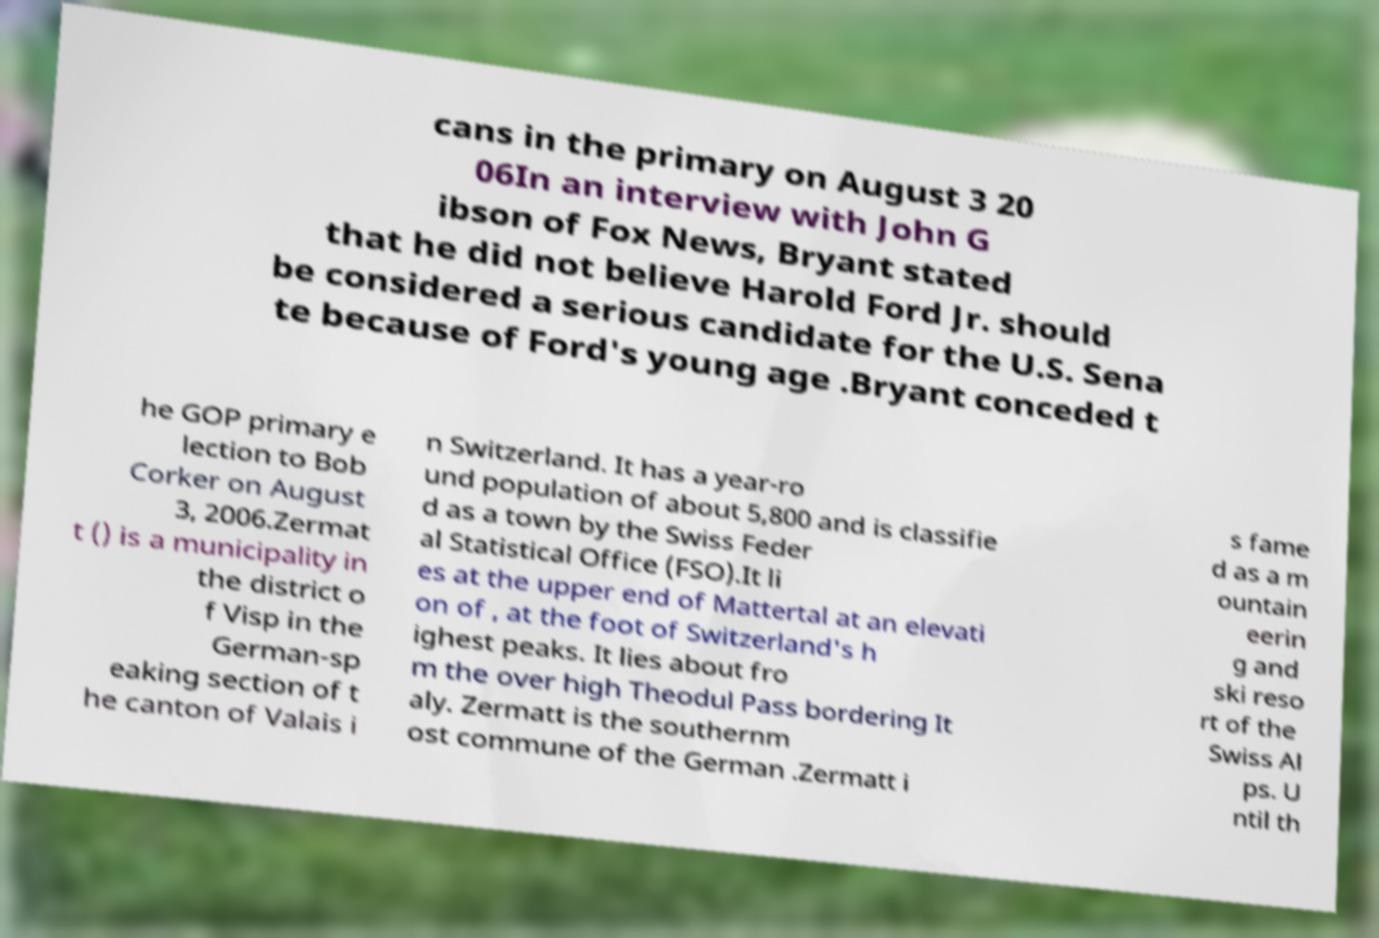There's text embedded in this image that I need extracted. Can you transcribe it verbatim? cans in the primary on August 3 20 06In an interview with John G ibson of Fox News, Bryant stated that he did not believe Harold Ford Jr. should be considered a serious candidate for the U.S. Sena te because of Ford's young age .Bryant conceded t he GOP primary e lection to Bob Corker on August 3, 2006.Zermat t () is a municipality in the district o f Visp in the German-sp eaking section of t he canton of Valais i n Switzerland. It has a year-ro und population of about 5,800 and is classifie d as a town by the Swiss Feder al Statistical Office (FSO).It li es at the upper end of Mattertal at an elevati on of , at the foot of Switzerland's h ighest peaks. It lies about fro m the over high Theodul Pass bordering It aly. Zermatt is the southernm ost commune of the German .Zermatt i s fame d as a m ountain eerin g and ski reso rt of the Swiss Al ps. U ntil th 